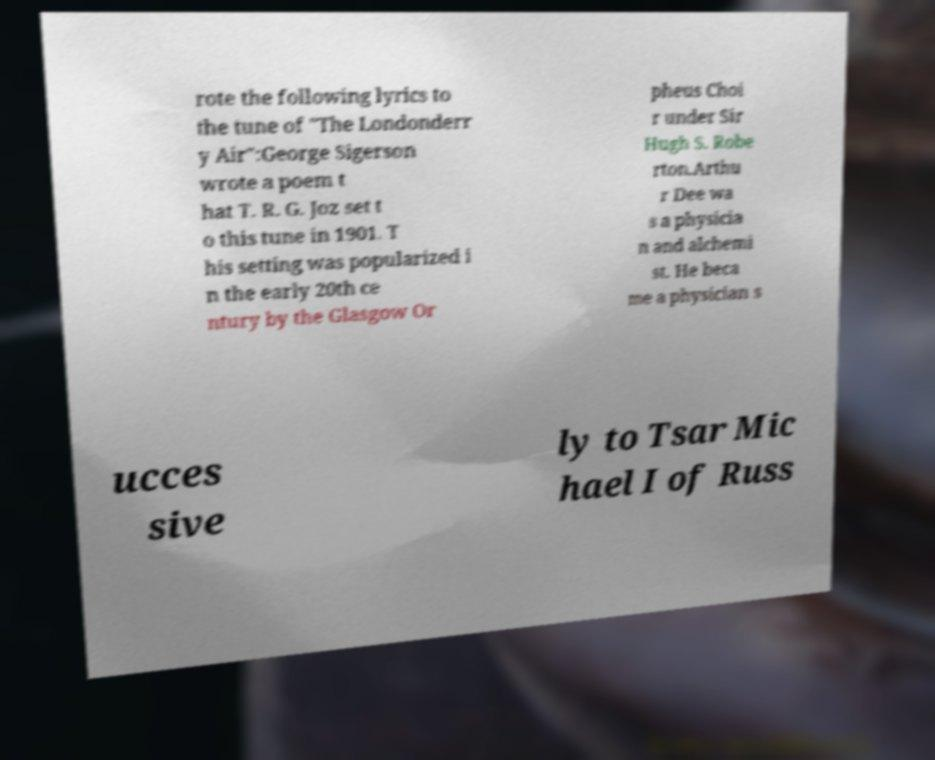Please identify and transcribe the text found in this image. rote the following lyrics to the tune of "The Londonderr y Air":George Sigerson wrote a poem t hat T. R. G. Joz set t o this tune in 1901. T his setting was popularized i n the early 20th ce ntury by the Glasgow Or pheus Choi r under Sir Hugh S. Robe rton.Arthu r Dee wa s a physicia n and alchemi st. He beca me a physician s ucces sive ly to Tsar Mic hael I of Russ 